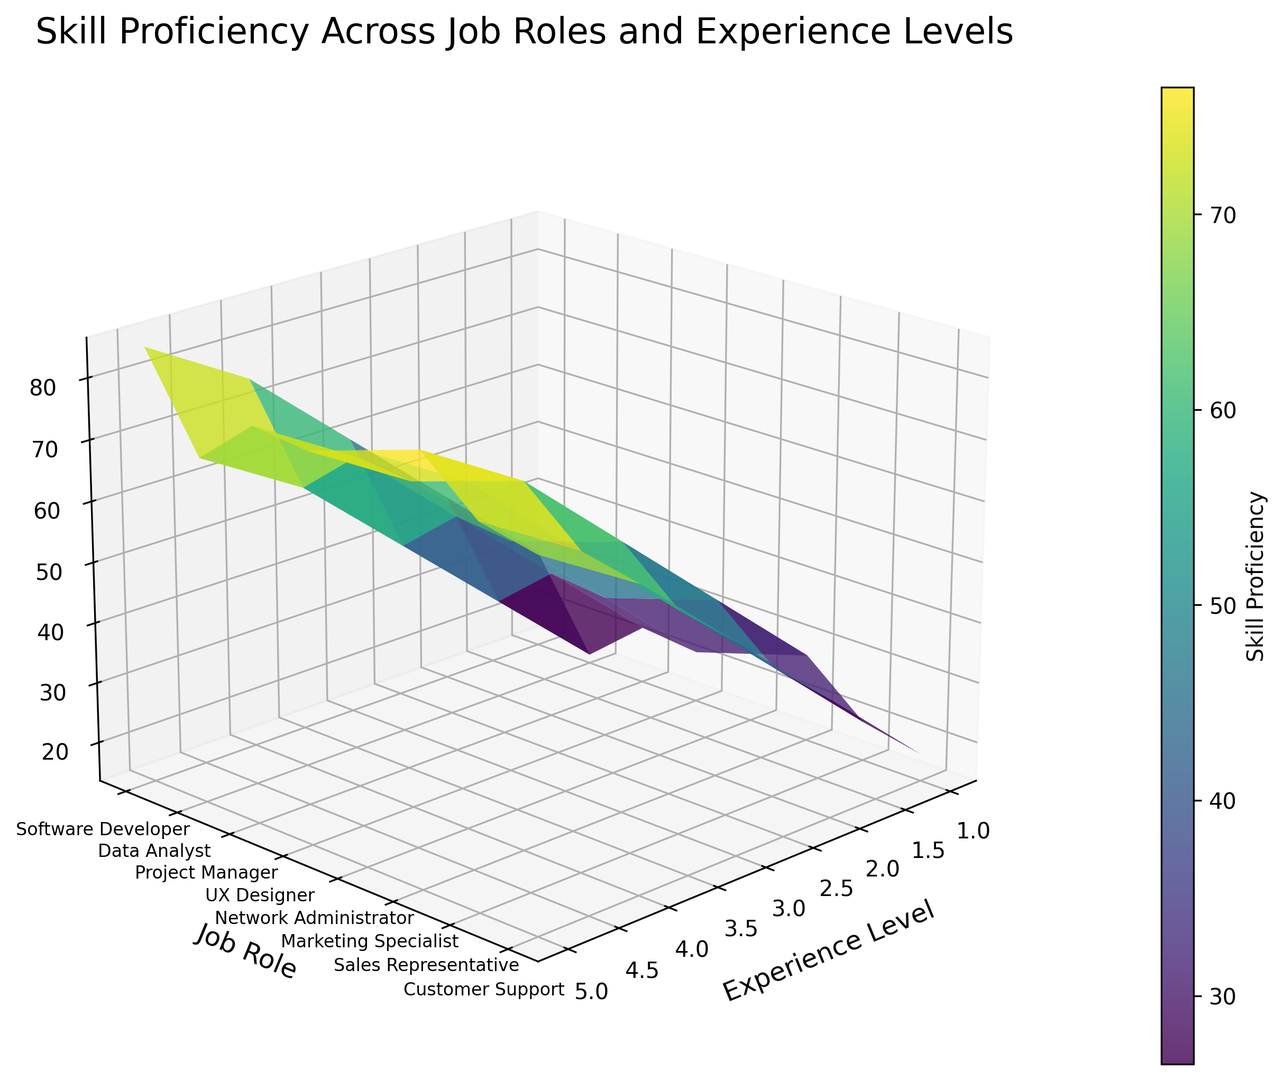What job role shows the highest skill proficiency at experience level 3? Look at the figure for the highest Z-value (skill proficiency) at experience level 3. Observe which job role corresponds to this value.
Answer: Sales Representative Which job role has the lowest initial skill proficiency at experience level 1? Inspect the figure to find the lowest starting point on the Z-axis at experience level 1. Identify the job role associated with this lowest point.
Answer: Data Analyst What is the difference in skill proficiency between the experience level 5 of Project Manager and Software Developer? Find the Z-values at experience level 5 for both Project Manager and Software Developer. Subtract the Z-value of Software Developer from that of Project Manager.
Answer: 5 (80 - 75) Which job role shows the most significant increase in skill proficiency from experience level 1 to level 5? Calculate the difference in Z-values between experience levels 1 and 5 for each job role. Identify which job role has the largest difference.
Answer: Customer Support At experience level 4, which job role has a skill proficiency closest to the average proficiency at this level across all job roles? Calculate the average of the Z-values at experience level 4 across all job roles. Compare individual job role Z-values at this level with the calculated average and find the closest one.
Answer: Sales Representative (73, average is approximately 67.5) Which job roles have a similar skill proficiency trend across increasing experience levels? Observe the 3D surface plot for similarities in the slope or shape of the surfaces representing different job roles across experience levels. Identify job roles that have parallel or very similar trends.
Answer: Software Developer and Data Analyst Which job role's skill proficiency changes most drastically between any two consecutive experience levels? Examine the steepness or rate of change in the Z-values between any two consecutive experience levels for all job roles. Determine which role has the most drastic change.
Answer: Customer Support (between level 4 and 5) What is the average skill proficiency for UX Designer across all experience levels? Sum the Z-values for UX Designer across all experience levels and then divide by the number of levels (5).
Answer: 47 How does the color gradient change for Network Administrator skill proficiency as experience level increases from 1 to 5? Look at the color changes on the surface representing the Network Administrator from experience level 1 to 5. Describe the gradient shift.
Answer: Gradually shifts from purple to yellow-green At which experience level does the Marketing Specialist reach half of their maximum skill proficiency? Determine the maximum Z-value for Marketing Specialist. Find the experience level where the Z-value is approximately half of this maximum.
Answer: Level 2 